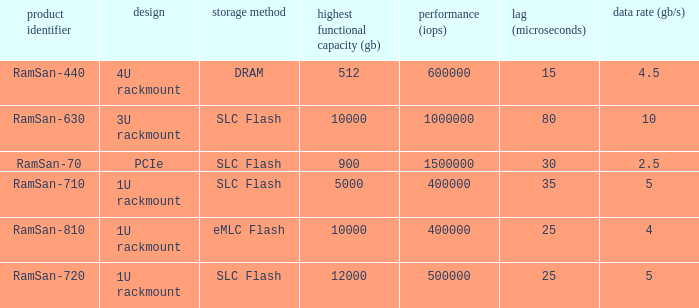List the range distroration for the ramsan-630 3U rackmount. 